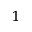Convert formula to latex. <formula><loc_0><loc_0><loc_500><loc_500>_ { 1 }</formula> 